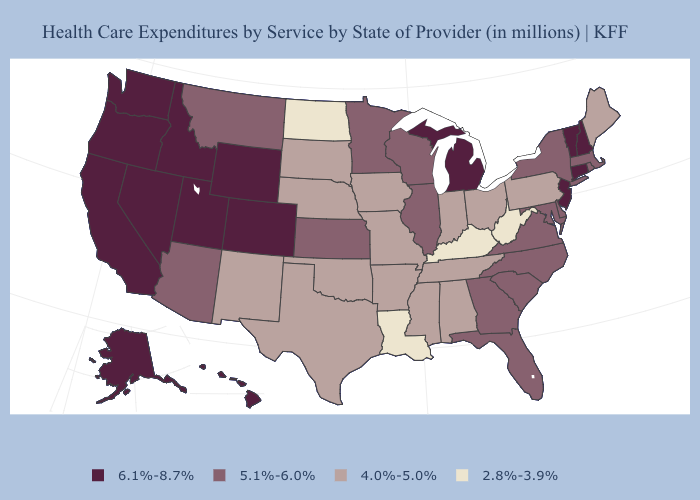What is the value of Pennsylvania?
Give a very brief answer. 4.0%-5.0%. What is the highest value in the USA?
Answer briefly. 6.1%-8.7%. Does Maryland have the highest value in the South?
Answer briefly. Yes. How many symbols are there in the legend?
Keep it brief. 4. Among the states that border Rhode Island , does Connecticut have the highest value?
Give a very brief answer. Yes. How many symbols are there in the legend?
Write a very short answer. 4. Does the map have missing data?
Write a very short answer. No. Does Oregon have the same value as Louisiana?
Short answer required. No. Is the legend a continuous bar?
Quick response, please. No. What is the value of California?
Be succinct. 6.1%-8.7%. Does the map have missing data?
Keep it brief. No. Name the states that have a value in the range 5.1%-6.0%?
Short answer required. Arizona, Delaware, Florida, Georgia, Illinois, Kansas, Maryland, Massachusetts, Minnesota, Montana, New York, North Carolina, Rhode Island, South Carolina, Virginia, Wisconsin. What is the value of Arkansas?
Answer briefly. 4.0%-5.0%. Name the states that have a value in the range 6.1%-8.7%?
Give a very brief answer. Alaska, California, Colorado, Connecticut, Hawaii, Idaho, Michigan, Nevada, New Hampshire, New Jersey, Oregon, Utah, Vermont, Washington, Wyoming. What is the value of Mississippi?
Answer briefly. 4.0%-5.0%. 